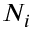Convert formula to latex. <formula><loc_0><loc_0><loc_500><loc_500>N _ { i }</formula> 